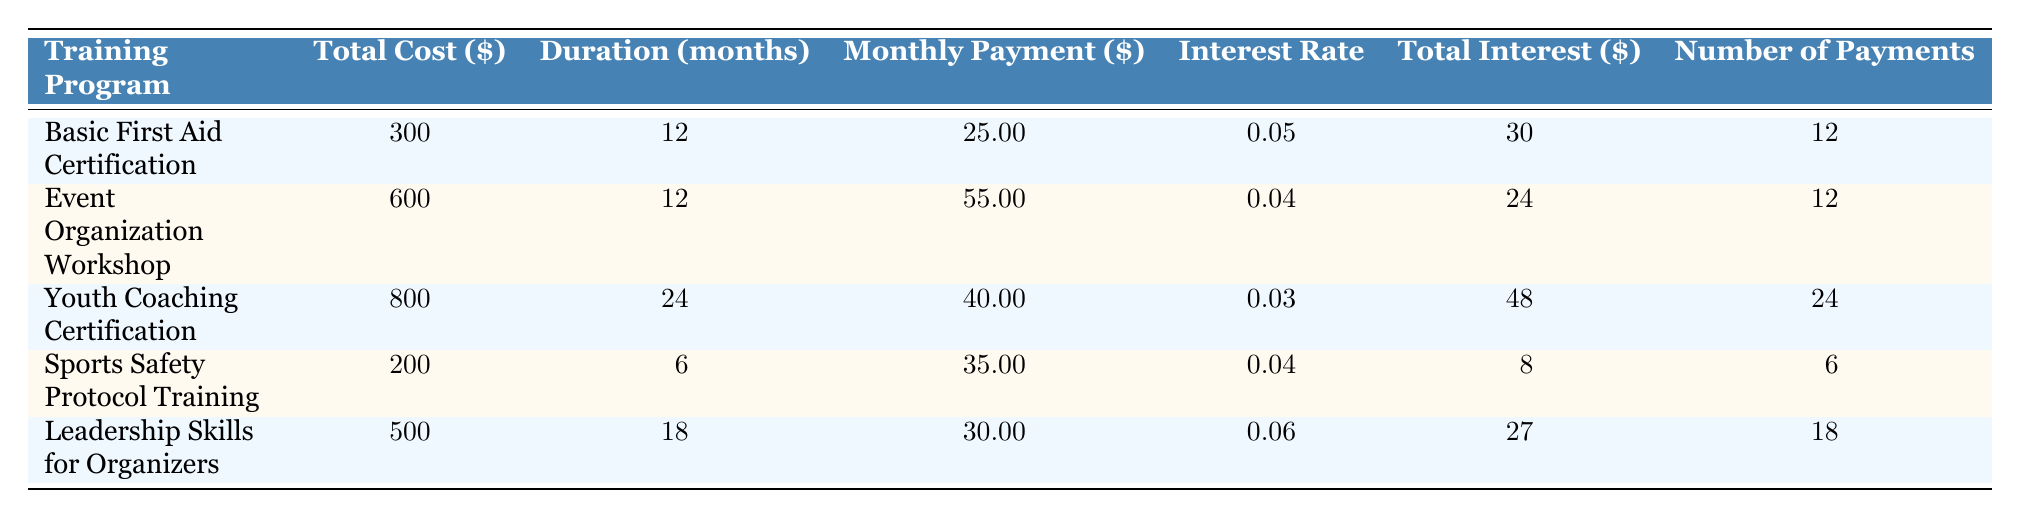What is the total cost of the Youth Coaching Certification program? The table provides the total cost for each training program, specifically for the Youth Coaching Certification program, which is listed as 800.
Answer: 800 How long is the duration of the Event Organization Workshop? The table shows the duration for each training program; for the Event Organization Workshop, it is clearly stated as 12 months.
Answer: 12 months What is the average monthly payment for all training programs? To find the average monthly payment, we add the monthly payments (25 + 55 + 40 + 35 + 30 = 185) and divide by the number of programs (5), resulting in an average of 185/5 = 37.
Answer: 37 Is there any training program with an interest rate of 0.06? By inspecting the interest rates listed in the table, we can see that the Leadership Skills for Organizers program has an interest rate of 0.06, confirming the statement is true.
Answer: Yes Which training program has the highest total interest paid? To find the program with the highest total interest, we compare the total interest values: 30, 24, 48, 8, and 27. The Youth Coaching Certification has the highest total interest at 48.
Answer: Youth Coaching Certification What is the difference in total cost between the Sports Safety Protocol Training and the Basic First Aid Certification? The total costs for both programs are 200 and 300, respectively. The difference is calculated as 300 - 200 = 100.
Answer: 100 Which program offers the longest duration? Reviewing the durations: 12, 12, 24, 6, and 18 months, the Youth Coaching Certification with 24 months is confirmed to be the longest duration.
Answer: Youth Coaching Certification Is the monthly payment for the Sports Safety Protocol Training higher than for the Leadership Skills for Organizers? The monthly payments for Sports Safety Protocol Training (35) and Leadership Skills for Organizers (30) show that 35 is greater than 30. Thus, the statement is true.
Answer: Yes What is the total number of payments required for the Event Organization Workshop? The table specifies the number of payments for each program; for the Event Organization Workshop, it shows a total of 12 payments.
Answer: 12 